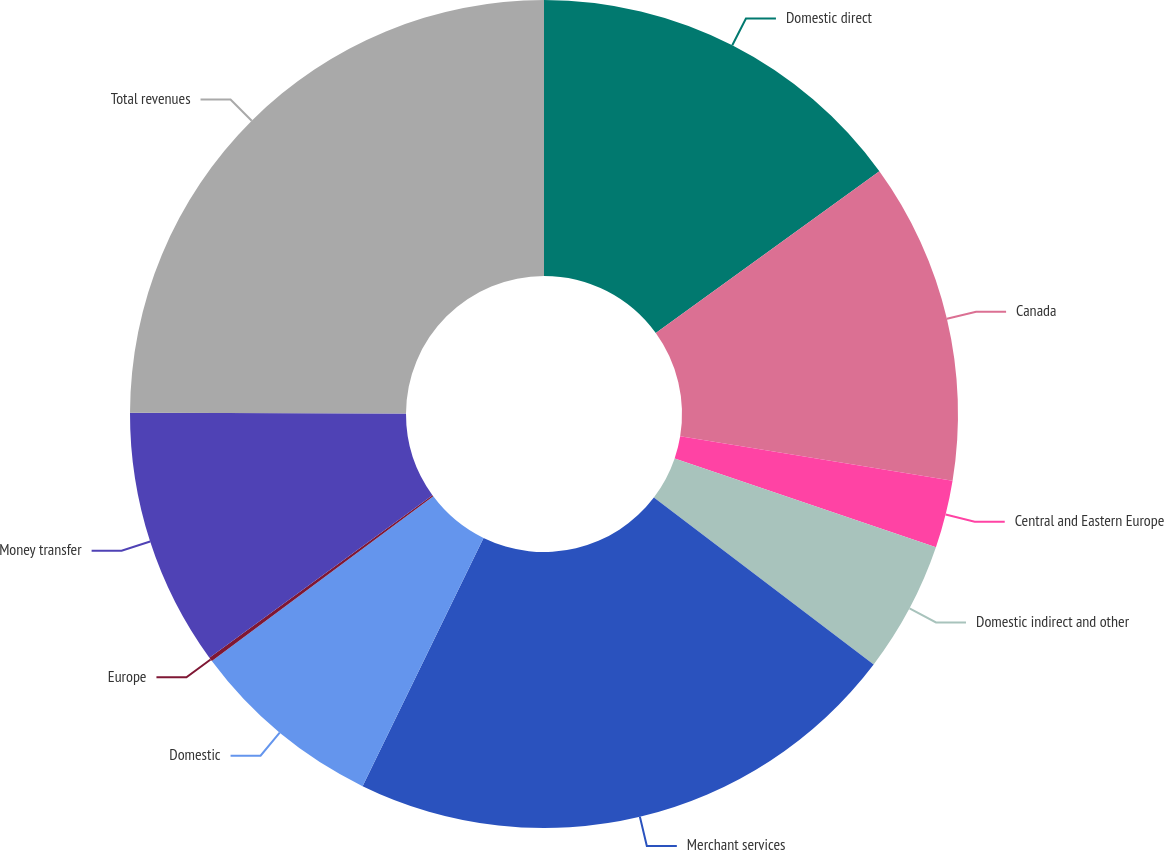Convert chart to OTSL. <chart><loc_0><loc_0><loc_500><loc_500><pie_chart><fcel>Domestic direct<fcel>Canada<fcel>Central and Eastern Europe<fcel>Domestic indirect and other<fcel>Merchant services<fcel>Domestic<fcel>Europe<fcel>Money transfer<fcel>Total revenues<nl><fcel>15.03%<fcel>12.55%<fcel>2.64%<fcel>5.12%<fcel>21.88%<fcel>7.6%<fcel>0.16%<fcel>10.07%<fcel>24.95%<nl></chart> 